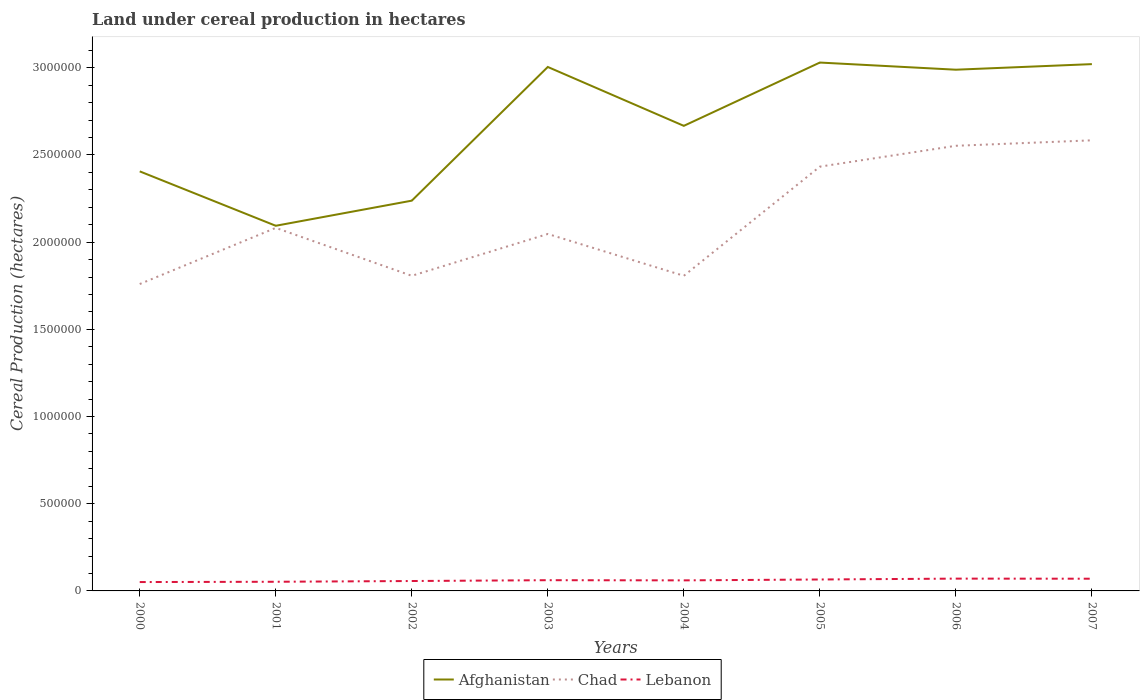Is the number of lines equal to the number of legend labels?
Offer a terse response. Yes. Across all years, what is the maximum land under cereal production in Lebanon?
Offer a very short reply. 5.08e+04. In which year was the land under cereal production in Chad maximum?
Give a very brief answer. 2000. What is the total land under cereal production in Afghanistan in the graph?
Provide a succinct answer. -7.67e+05. What is the difference between the highest and the second highest land under cereal production in Lebanon?
Keep it short and to the point. 1.97e+04. What is the difference between the highest and the lowest land under cereal production in Afghanistan?
Your answer should be very brief. 4. Is the land under cereal production in Chad strictly greater than the land under cereal production in Afghanistan over the years?
Provide a short and direct response. Yes. How many lines are there?
Your answer should be compact. 3. How many years are there in the graph?
Make the answer very short. 8. Are the values on the major ticks of Y-axis written in scientific E-notation?
Offer a very short reply. No. Where does the legend appear in the graph?
Provide a succinct answer. Bottom center. How are the legend labels stacked?
Keep it short and to the point. Horizontal. What is the title of the graph?
Provide a succinct answer. Land under cereal production in hectares. Does "Bolivia" appear as one of the legend labels in the graph?
Your answer should be compact. No. What is the label or title of the X-axis?
Provide a short and direct response. Years. What is the label or title of the Y-axis?
Make the answer very short. Cereal Production (hectares). What is the Cereal Production (hectares) of Afghanistan in 2000?
Ensure brevity in your answer.  2.41e+06. What is the Cereal Production (hectares) in Chad in 2000?
Offer a terse response. 1.76e+06. What is the Cereal Production (hectares) of Lebanon in 2000?
Ensure brevity in your answer.  5.08e+04. What is the Cereal Production (hectares) in Afghanistan in 2001?
Offer a terse response. 2.09e+06. What is the Cereal Production (hectares) of Chad in 2001?
Make the answer very short. 2.08e+06. What is the Cereal Production (hectares) of Lebanon in 2001?
Ensure brevity in your answer.  5.25e+04. What is the Cereal Production (hectares) in Afghanistan in 2002?
Provide a short and direct response. 2.24e+06. What is the Cereal Production (hectares) in Chad in 2002?
Your response must be concise. 1.81e+06. What is the Cereal Production (hectares) of Lebanon in 2002?
Offer a terse response. 5.68e+04. What is the Cereal Production (hectares) in Afghanistan in 2003?
Your answer should be compact. 3.00e+06. What is the Cereal Production (hectares) of Chad in 2003?
Provide a succinct answer. 2.05e+06. What is the Cereal Production (hectares) in Lebanon in 2003?
Offer a terse response. 6.15e+04. What is the Cereal Production (hectares) of Afghanistan in 2004?
Offer a terse response. 2.67e+06. What is the Cereal Production (hectares) in Chad in 2004?
Keep it short and to the point. 1.81e+06. What is the Cereal Production (hectares) of Lebanon in 2004?
Provide a succinct answer. 6.05e+04. What is the Cereal Production (hectares) of Afghanistan in 2005?
Offer a very short reply. 3.03e+06. What is the Cereal Production (hectares) in Chad in 2005?
Provide a short and direct response. 2.43e+06. What is the Cereal Production (hectares) of Lebanon in 2005?
Give a very brief answer. 6.56e+04. What is the Cereal Production (hectares) of Afghanistan in 2006?
Ensure brevity in your answer.  2.99e+06. What is the Cereal Production (hectares) of Chad in 2006?
Your response must be concise. 2.55e+06. What is the Cereal Production (hectares) of Lebanon in 2006?
Make the answer very short. 7.05e+04. What is the Cereal Production (hectares) in Afghanistan in 2007?
Your answer should be very brief. 3.02e+06. What is the Cereal Production (hectares) of Chad in 2007?
Provide a succinct answer. 2.58e+06. What is the Cereal Production (hectares) in Lebanon in 2007?
Give a very brief answer. 7.00e+04. Across all years, what is the maximum Cereal Production (hectares) of Afghanistan?
Provide a short and direct response. 3.03e+06. Across all years, what is the maximum Cereal Production (hectares) in Chad?
Your answer should be very brief. 2.58e+06. Across all years, what is the maximum Cereal Production (hectares) of Lebanon?
Keep it short and to the point. 7.05e+04. Across all years, what is the minimum Cereal Production (hectares) in Afghanistan?
Ensure brevity in your answer.  2.09e+06. Across all years, what is the minimum Cereal Production (hectares) in Chad?
Provide a short and direct response. 1.76e+06. Across all years, what is the minimum Cereal Production (hectares) in Lebanon?
Make the answer very short. 5.08e+04. What is the total Cereal Production (hectares) in Afghanistan in the graph?
Your answer should be compact. 2.14e+07. What is the total Cereal Production (hectares) in Chad in the graph?
Your response must be concise. 1.71e+07. What is the total Cereal Production (hectares) in Lebanon in the graph?
Provide a short and direct response. 4.88e+05. What is the difference between the Cereal Production (hectares) in Afghanistan in 2000 and that in 2001?
Your answer should be very brief. 3.12e+05. What is the difference between the Cereal Production (hectares) of Chad in 2000 and that in 2001?
Give a very brief answer. -3.22e+05. What is the difference between the Cereal Production (hectares) of Lebanon in 2000 and that in 2001?
Offer a terse response. -1679. What is the difference between the Cereal Production (hectares) in Afghanistan in 2000 and that in 2002?
Offer a terse response. 1.68e+05. What is the difference between the Cereal Production (hectares) in Chad in 2000 and that in 2002?
Give a very brief answer. -4.72e+04. What is the difference between the Cereal Production (hectares) in Lebanon in 2000 and that in 2002?
Ensure brevity in your answer.  -5946. What is the difference between the Cereal Production (hectares) in Afghanistan in 2000 and that in 2003?
Your answer should be compact. -5.99e+05. What is the difference between the Cereal Production (hectares) of Chad in 2000 and that in 2003?
Offer a very short reply. -2.87e+05. What is the difference between the Cereal Production (hectares) in Lebanon in 2000 and that in 2003?
Your answer should be compact. -1.07e+04. What is the difference between the Cereal Production (hectares) in Afghanistan in 2000 and that in 2004?
Provide a succinct answer. -2.61e+05. What is the difference between the Cereal Production (hectares) of Chad in 2000 and that in 2004?
Provide a succinct answer. -4.72e+04. What is the difference between the Cereal Production (hectares) of Lebanon in 2000 and that in 2004?
Ensure brevity in your answer.  -9691. What is the difference between the Cereal Production (hectares) of Afghanistan in 2000 and that in 2005?
Your answer should be compact. -6.24e+05. What is the difference between the Cereal Production (hectares) in Chad in 2000 and that in 2005?
Offer a very short reply. -6.73e+05. What is the difference between the Cereal Production (hectares) of Lebanon in 2000 and that in 2005?
Your answer should be very brief. -1.47e+04. What is the difference between the Cereal Production (hectares) of Afghanistan in 2000 and that in 2006?
Keep it short and to the point. -5.83e+05. What is the difference between the Cereal Production (hectares) in Chad in 2000 and that in 2006?
Offer a very short reply. -7.93e+05. What is the difference between the Cereal Production (hectares) in Lebanon in 2000 and that in 2006?
Make the answer very short. -1.97e+04. What is the difference between the Cereal Production (hectares) of Afghanistan in 2000 and that in 2007?
Keep it short and to the point. -6.15e+05. What is the difference between the Cereal Production (hectares) in Chad in 2000 and that in 2007?
Give a very brief answer. -8.24e+05. What is the difference between the Cereal Production (hectares) of Lebanon in 2000 and that in 2007?
Your answer should be very brief. -1.92e+04. What is the difference between the Cereal Production (hectares) of Afghanistan in 2001 and that in 2002?
Ensure brevity in your answer.  -1.44e+05. What is the difference between the Cereal Production (hectares) of Chad in 2001 and that in 2002?
Your response must be concise. 2.75e+05. What is the difference between the Cereal Production (hectares) in Lebanon in 2001 and that in 2002?
Your answer should be very brief. -4267. What is the difference between the Cereal Production (hectares) of Afghanistan in 2001 and that in 2003?
Your answer should be very brief. -9.11e+05. What is the difference between the Cereal Production (hectares) of Chad in 2001 and that in 2003?
Offer a terse response. 3.49e+04. What is the difference between the Cereal Production (hectares) in Lebanon in 2001 and that in 2003?
Offer a very short reply. -8992. What is the difference between the Cereal Production (hectares) in Afghanistan in 2001 and that in 2004?
Offer a terse response. -5.73e+05. What is the difference between the Cereal Production (hectares) of Chad in 2001 and that in 2004?
Offer a very short reply. 2.75e+05. What is the difference between the Cereal Production (hectares) in Lebanon in 2001 and that in 2004?
Offer a very short reply. -8012. What is the difference between the Cereal Production (hectares) of Afghanistan in 2001 and that in 2005?
Give a very brief answer. -9.36e+05. What is the difference between the Cereal Production (hectares) in Chad in 2001 and that in 2005?
Your answer should be very brief. -3.51e+05. What is the difference between the Cereal Production (hectares) of Lebanon in 2001 and that in 2005?
Provide a succinct answer. -1.30e+04. What is the difference between the Cereal Production (hectares) in Afghanistan in 2001 and that in 2006?
Your answer should be very brief. -8.95e+05. What is the difference between the Cereal Production (hectares) of Chad in 2001 and that in 2006?
Ensure brevity in your answer.  -4.71e+05. What is the difference between the Cereal Production (hectares) of Lebanon in 2001 and that in 2006?
Your answer should be very brief. -1.80e+04. What is the difference between the Cereal Production (hectares) of Afghanistan in 2001 and that in 2007?
Make the answer very short. -9.27e+05. What is the difference between the Cereal Production (hectares) in Chad in 2001 and that in 2007?
Provide a succinct answer. -5.02e+05. What is the difference between the Cereal Production (hectares) in Lebanon in 2001 and that in 2007?
Ensure brevity in your answer.  -1.75e+04. What is the difference between the Cereal Production (hectares) in Afghanistan in 2002 and that in 2003?
Keep it short and to the point. -7.67e+05. What is the difference between the Cereal Production (hectares) in Chad in 2002 and that in 2003?
Offer a terse response. -2.40e+05. What is the difference between the Cereal Production (hectares) in Lebanon in 2002 and that in 2003?
Make the answer very short. -4725. What is the difference between the Cereal Production (hectares) in Afghanistan in 2002 and that in 2004?
Offer a very short reply. -4.29e+05. What is the difference between the Cereal Production (hectares) in Chad in 2002 and that in 2004?
Ensure brevity in your answer.  18. What is the difference between the Cereal Production (hectares) of Lebanon in 2002 and that in 2004?
Offer a very short reply. -3745. What is the difference between the Cereal Production (hectares) in Afghanistan in 2002 and that in 2005?
Give a very brief answer. -7.92e+05. What is the difference between the Cereal Production (hectares) in Chad in 2002 and that in 2005?
Keep it short and to the point. -6.26e+05. What is the difference between the Cereal Production (hectares) of Lebanon in 2002 and that in 2005?
Provide a succinct answer. -8774. What is the difference between the Cereal Production (hectares) of Afghanistan in 2002 and that in 2006?
Your response must be concise. -7.51e+05. What is the difference between the Cereal Production (hectares) of Chad in 2002 and that in 2006?
Your answer should be compact. -7.46e+05. What is the difference between the Cereal Production (hectares) in Lebanon in 2002 and that in 2006?
Your response must be concise. -1.37e+04. What is the difference between the Cereal Production (hectares) of Afghanistan in 2002 and that in 2007?
Your response must be concise. -7.83e+05. What is the difference between the Cereal Production (hectares) of Chad in 2002 and that in 2007?
Give a very brief answer. -7.77e+05. What is the difference between the Cereal Production (hectares) of Lebanon in 2002 and that in 2007?
Your answer should be very brief. -1.32e+04. What is the difference between the Cereal Production (hectares) in Afghanistan in 2003 and that in 2004?
Your answer should be compact. 3.38e+05. What is the difference between the Cereal Production (hectares) of Chad in 2003 and that in 2004?
Provide a short and direct response. 2.40e+05. What is the difference between the Cereal Production (hectares) of Lebanon in 2003 and that in 2004?
Your response must be concise. 980. What is the difference between the Cereal Production (hectares) in Afghanistan in 2003 and that in 2005?
Offer a very short reply. -2.53e+04. What is the difference between the Cereal Production (hectares) in Chad in 2003 and that in 2005?
Your answer should be very brief. -3.86e+05. What is the difference between the Cereal Production (hectares) of Lebanon in 2003 and that in 2005?
Give a very brief answer. -4049. What is the difference between the Cereal Production (hectares) of Afghanistan in 2003 and that in 2006?
Your answer should be compact. 1.57e+04. What is the difference between the Cereal Production (hectares) in Chad in 2003 and that in 2006?
Ensure brevity in your answer.  -5.06e+05. What is the difference between the Cereal Production (hectares) of Lebanon in 2003 and that in 2006?
Provide a short and direct response. -9024. What is the difference between the Cereal Production (hectares) of Afghanistan in 2003 and that in 2007?
Your answer should be very brief. -1.63e+04. What is the difference between the Cereal Production (hectares) in Chad in 2003 and that in 2007?
Give a very brief answer. -5.37e+05. What is the difference between the Cereal Production (hectares) of Lebanon in 2003 and that in 2007?
Provide a succinct answer. -8519. What is the difference between the Cereal Production (hectares) of Afghanistan in 2004 and that in 2005?
Keep it short and to the point. -3.63e+05. What is the difference between the Cereal Production (hectares) of Chad in 2004 and that in 2005?
Your answer should be compact. -6.26e+05. What is the difference between the Cereal Production (hectares) of Lebanon in 2004 and that in 2005?
Make the answer very short. -5029. What is the difference between the Cereal Production (hectares) of Afghanistan in 2004 and that in 2006?
Your answer should be very brief. -3.22e+05. What is the difference between the Cereal Production (hectares) of Chad in 2004 and that in 2006?
Give a very brief answer. -7.46e+05. What is the difference between the Cereal Production (hectares) in Lebanon in 2004 and that in 2006?
Make the answer very short. -1.00e+04. What is the difference between the Cereal Production (hectares) in Afghanistan in 2004 and that in 2007?
Make the answer very short. -3.54e+05. What is the difference between the Cereal Production (hectares) in Chad in 2004 and that in 2007?
Provide a short and direct response. -7.77e+05. What is the difference between the Cereal Production (hectares) of Lebanon in 2004 and that in 2007?
Provide a succinct answer. -9499. What is the difference between the Cereal Production (hectares) in Afghanistan in 2005 and that in 2006?
Provide a succinct answer. 4.10e+04. What is the difference between the Cereal Production (hectares) of Chad in 2005 and that in 2006?
Give a very brief answer. -1.20e+05. What is the difference between the Cereal Production (hectares) in Lebanon in 2005 and that in 2006?
Provide a short and direct response. -4975. What is the difference between the Cereal Production (hectares) in Afghanistan in 2005 and that in 2007?
Make the answer very short. 9000. What is the difference between the Cereal Production (hectares) in Chad in 2005 and that in 2007?
Provide a short and direct response. -1.51e+05. What is the difference between the Cereal Production (hectares) in Lebanon in 2005 and that in 2007?
Give a very brief answer. -4470. What is the difference between the Cereal Production (hectares) of Afghanistan in 2006 and that in 2007?
Provide a short and direct response. -3.20e+04. What is the difference between the Cereal Production (hectares) in Chad in 2006 and that in 2007?
Ensure brevity in your answer.  -3.13e+04. What is the difference between the Cereal Production (hectares) of Lebanon in 2006 and that in 2007?
Offer a terse response. 505. What is the difference between the Cereal Production (hectares) of Afghanistan in 2000 and the Cereal Production (hectares) of Chad in 2001?
Your response must be concise. 3.24e+05. What is the difference between the Cereal Production (hectares) of Afghanistan in 2000 and the Cereal Production (hectares) of Lebanon in 2001?
Offer a very short reply. 2.35e+06. What is the difference between the Cereal Production (hectares) of Chad in 2000 and the Cereal Production (hectares) of Lebanon in 2001?
Give a very brief answer. 1.71e+06. What is the difference between the Cereal Production (hectares) in Afghanistan in 2000 and the Cereal Production (hectares) in Chad in 2002?
Make the answer very short. 5.99e+05. What is the difference between the Cereal Production (hectares) in Afghanistan in 2000 and the Cereal Production (hectares) in Lebanon in 2002?
Your answer should be very brief. 2.35e+06. What is the difference between the Cereal Production (hectares) in Chad in 2000 and the Cereal Production (hectares) in Lebanon in 2002?
Ensure brevity in your answer.  1.70e+06. What is the difference between the Cereal Production (hectares) in Afghanistan in 2000 and the Cereal Production (hectares) in Chad in 2003?
Offer a terse response. 3.59e+05. What is the difference between the Cereal Production (hectares) in Afghanistan in 2000 and the Cereal Production (hectares) in Lebanon in 2003?
Offer a terse response. 2.34e+06. What is the difference between the Cereal Production (hectares) in Chad in 2000 and the Cereal Production (hectares) in Lebanon in 2003?
Make the answer very short. 1.70e+06. What is the difference between the Cereal Production (hectares) in Afghanistan in 2000 and the Cereal Production (hectares) in Chad in 2004?
Provide a short and direct response. 5.99e+05. What is the difference between the Cereal Production (hectares) of Afghanistan in 2000 and the Cereal Production (hectares) of Lebanon in 2004?
Offer a terse response. 2.35e+06. What is the difference between the Cereal Production (hectares) in Chad in 2000 and the Cereal Production (hectares) in Lebanon in 2004?
Your response must be concise. 1.70e+06. What is the difference between the Cereal Production (hectares) of Afghanistan in 2000 and the Cereal Production (hectares) of Chad in 2005?
Your answer should be very brief. -2.71e+04. What is the difference between the Cereal Production (hectares) of Afghanistan in 2000 and the Cereal Production (hectares) of Lebanon in 2005?
Offer a very short reply. 2.34e+06. What is the difference between the Cereal Production (hectares) in Chad in 2000 and the Cereal Production (hectares) in Lebanon in 2005?
Provide a short and direct response. 1.69e+06. What is the difference between the Cereal Production (hectares) of Afghanistan in 2000 and the Cereal Production (hectares) of Chad in 2006?
Ensure brevity in your answer.  -1.47e+05. What is the difference between the Cereal Production (hectares) in Afghanistan in 2000 and the Cereal Production (hectares) in Lebanon in 2006?
Give a very brief answer. 2.34e+06. What is the difference between the Cereal Production (hectares) of Chad in 2000 and the Cereal Production (hectares) of Lebanon in 2006?
Provide a short and direct response. 1.69e+06. What is the difference between the Cereal Production (hectares) of Afghanistan in 2000 and the Cereal Production (hectares) of Chad in 2007?
Your response must be concise. -1.78e+05. What is the difference between the Cereal Production (hectares) in Afghanistan in 2000 and the Cereal Production (hectares) in Lebanon in 2007?
Give a very brief answer. 2.34e+06. What is the difference between the Cereal Production (hectares) in Chad in 2000 and the Cereal Production (hectares) in Lebanon in 2007?
Keep it short and to the point. 1.69e+06. What is the difference between the Cereal Production (hectares) of Afghanistan in 2001 and the Cereal Production (hectares) of Chad in 2002?
Provide a short and direct response. 2.87e+05. What is the difference between the Cereal Production (hectares) in Afghanistan in 2001 and the Cereal Production (hectares) in Lebanon in 2002?
Keep it short and to the point. 2.04e+06. What is the difference between the Cereal Production (hectares) of Chad in 2001 and the Cereal Production (hectares) of Lebanon in 2002?
Ensure brevity in your answer.  2.03e+06. What is the difference between the Cereal Production (hectares) in Afghanistan in 2001 and the Cereal Production (hectares) in Chad in 2003?
Your response must be concise. 4.70e+04. What is the difference between the Cereal Production (hectares) of Afghanistan in 2001 and the Cereal Production (hectares) of Lebanon in 2003?
Provide a succinct answer. 2.03e+06. What is the difference between the Cereal Production (hectares) of Chad in 2001 and the Cereal Production (hectares) of Lebanon in 2003?
Provide a succinct answer. 2.02e+06. What is the difference between the Cereal Production (hectares) of Afghanistan in 2001 and the Cereal Production (hectares) of Chad in 2004?
Ensure brevity in your answer.  2.87e+05. What is the difference between the Cereal Production (hectares) in Afghanistan in 2001 and the Cereal Production (hectares) in Lebanon in 2004?
Your answer should be compact. 2.03e+06. What is the difference between the Cereal Production (hectares) in Chad in 2001 and the Cereal Production (hectares) in Lebanon in 2004?
Offer a very short reply. 2.02e+06. What is the difference between the Cereal Production (hectares) in Afghanistan in 2001 and the Cereal Production (hectares) in Chad in 2005?
Provide a succinct answer. -3.39e+05. What is the difference between the Cereal Production (hectares) of Afghanistan in 2001 and the Cereal Production (hectares) of Lebanon in 2005?
Provide a succinct answer. 2.03e+06. What is the difference between the Cereal Production (hectares) of Chad in 2001 and the Cereal Production (hectares) of Lebanon in 2005?
Ensure brevity in your answer.  2.02e+06. What is the difference between the Cereal Production (hectares) in Afghanistan in 2001 and the Cereal Production (hectares) in Chad in 2006?
Keep it short and to the point. -4.59e+05. What is the difference between the Cereal Production (hectares) in Afghanistan in 2001 and the Cereal Production (hectares) in Lebanon in 2006?
Offer a very short reply. 2.02e+06. What is the difference between the Cereal Production (hectares) in Chad in 2001 and the Cereal Production (hectares) in Lebanon in 2006?
Your answer should be very brief. 2.01e+06. What is the difference between the Cereal Production (hectares) in Afghanistan in 2001 and the Cereal Production (hectares) in Chad in 2007?
Provide a short and direct response. -4.90e+05. What is the difference between the Cereal Production (hectares) in Afghanistan in 2001 and the Cereal Production (hectares) in Lebanon in 2007?
Your answer should be very brief. 2.02e+06. What is the difference between the Cereal Production (hectares) in Chad in 2001 and the Cereal Production (hectares) in Lebanon in 2007?
Give a very brief answer. 2.01e+06. What is the difference between the Cereal Production (hectares) of Afghanistan in 2002 and the Cereal Production (hectares) of Chad in 2003?
Give a very brief answer. 1.91e+05. What is the difference between the Cereal Production (hectares) in Afghanistan in 2002 and the Cereal Production (hectares) in Lebanon in 2003?
Offer a terse response. 2.18e+06. What is the difference between the Cereal Production (hectares) of Chad in 2002 and the Cereal Production (hectares) of Lebanon in 2003?
Your answer should be very brief. 1.75e+06. What is the difference between the Cereal Production (hectares) in Afghanistan in 2002 and the Cereal Production (hectares) in Chad in 2004?
Your answer should be compact. 4.31e+05. What is the difference between the Cereal Production (hectares) in Afghanistan in 2002 and the Cereal Production (hectares) in Lebanon in 2004?
Keep it short and to the point. 2.18e+06. What is the difference between the Cereal Production (hectares) of Chad in 2002 and the Cereal Production (hectares) of Lebanon in 2004?
Provide a succinct answer. 1.75e+06. What is the difference between the Cereal Production (hectares) of Afghanistan in 2002 and the Cereal Production (hectares) of Chad in 2005?
Give a very brief answer. -1.95e+05. What is the difference between the Cereal Production (hectares) of Afghanistan in 2002 and the Cereal Production (hectares) of Lebanon in 2005?
Provide a short and direct response. 2.17e+06. What is the difference between the Cereal Production (hectares) in Chad in 2002 and the Cereal Production (hectares) in Lebanon in 2005?
Keep it short and to the point. 1.74e+06. What is the difference between the Cereal Production (hectares) in Afghanistan in 2002 and the Cereal Production (hectares) in Chad in 2006?
Your answer should be very brief. -3.15e+05. What is the difference between the Cereal Production (hectares) of Afghanistan in 2002 and the Cereal Production (hectares) of Lebanon in 2006?
Provide a succinct answer. 2.17e+06. What is the difference between the Cereal Production (hectares) in Chad in 2002 and the Cereal Production (hectares) in Lebanon in 2006?
Give a very brief answer. 1.74e+06. What is the difference between the Cereal Production (hectares) of Afghanistan in 2002 and the Cereal Production (hectares) of Chad in 2007?
Keep it short and to the point. -3.46e+05. What is the difference between the Cereal Production (hectares) in Afghanistan in 2002 and the Cereal Production (hectares) in Lebanon in 2007?
Make the answer very short. 2.17e+06. What is the difference between the Cereal Production (hectares) in Chad in 2002 and the Cereal Production (hectares) in Lebanon in 2007?
Make the answer very short. 1.74e+06. What is the difference between the Cereal Production (hectares) in Afghanistan in 2003 and the Cereal Production (hectares) in Chad in 2004?
Make the answer very short. 1.20e+06. What is the difference between the Cereal Production (hectares) of Afghanistan in 2003 and the Cereal Production (hectares) of Lebanon in 2004?
Give a very brief answer. 2.94e+06. What is the difference between the Cereal Production (hectares) of Chad in 2003 and the Cereal Production (hectares) of Lebanon in 2004?
Provide a short and direct response. 1.99e+06. What is the difference between the Cereal Production (hectares) of Afghanistan in 2003 and the Cereal Production (hectares) of Chad in 2005?
Keep it short and to the point. 5.72e+05. What is the difference between the Cereal Production (hectares) in Afghanistan in 2003 and the Cereal Production (hectares) in Lebanon in 2005?
Keep it short and to the point. 2.94e+06. What is the difference between the Cereal Production (hectares) in Chad in 2003 and the Cereal Production (hectares) in Lebanon in 2005?
Give a very brief answer. 1.98e+06. What is the difference between the Cereal Production (hectares) in Afghanistan in 2003 and the Cereal Production (hectares) in Chad in 2006?
Offer a very short reply. 4.52e+05. What is the difference between the Cereal Production (hectares) in Afghanistan in 2003 and the Cereal Production (hectares) in Lebanon in 2006?
Provide a short and direct response. 2.93e+06. What is the difference between the Cereal Production (hectares) of Chad in 2003 and the Cereal Production (hectares) of Lebanon in 2006?
Offer a terse response. 1.98e+06. What is the difference between the Cereal Production (hectares) of Afghanistan in 2003 and the Cereal Production (hectares) of Chad in 2007?
Provide a succinct answer. 4.21e+05. What is the difference between the Cereal Production (hectares) of Afghanistan in 2003 and the Cereal Production (hectares) of Lebanon in 2007?
Make the answer very short. 2.93e+06. What is the difference between the Cereal Production (hectares) of Chad in 2003 and the Cereal Production (hectares) of Lebanon in 2007?
Ensure brevity in your answer.  1.98e+06. What is the difference between the Cereal Production (hectares) in Afghanistan in 2004 and the Cereal Production (hectares) in Chad in 2005?
Provide a succinct answer. 2.34e+05. What is the difference between the Cereal Production (hectares) in Afghanistan in 2004 and the Cereal Production (hectares) in Lebanon in 2005?
Provide a succinct answer. 2.60e+06. What is the difference between the Cereal Production (hectares) in Chad in 2004 and the Cereal Production (hectares) in Lebanon in 2005?
Keep it short and to the point. 1.74e+06. What is the difference between the Cereal Production (hectares) in Afghanistan in 2004 and the Cereal Production (hectares) in Chad in 2006?
Offer a very short reply. 1.14e+05. What is the difference between the Cereal Production (hectares) in Afghanistan in 2004 and the Cereal Production (hectares) in Lebanon in 2006?
Offer a terse response. 2.60e+06. What is the difference between the Cereal Production (hectares) of Chad in 2004 and the Cereal Production (hectares) of Lebanon in 2006?
Offer a very short reply. 1.74e+06. What is the difference between the Cereal Production (hectares) of Afghanistan in 2004 and the Cereal Production (hectares) of Chad in 2007?
Provide a succinct answer. 8.30e+04. What is the difference between the Cereal Production (hectares) in Afghanistan in 2004 and the Cereal Production (hectares) in Lebanon in 2007?
Keep it short and to the point. 2.60e+06. What is the difference between the Cereal Production (hectares) of Chad in 2004 and the Cereal Production (hectares) of Lebanon in 2007?
Provide a succinct answer. 1.74e+06. What is the difference between the Cereal Production (hectares) of Afghanistan in 2005 and the Cereal Production (hectares) of Chad in 2006?
Make the answer very short. 4.77e+05. What is the difference between the Cereal Production (hectares) in Afghanistan in 2005 and the Cereal Production (hectares) in Lebanon in 2006?
Make the answer very short. 2.96e+06. What is the difference between the Cereal Production (hectares) in Chad in 2005 and the Cereal Production (hectares) in Lebanon in 2006?
Provide a short and direct response. 2.36e+06. What is the difference between the Cereal Production (hectares) of Afghanistan in 2005 and the Cereal Production (hectares) of Chad in 2007?
Provide a succinct answer. 4.46e+05. What is the difference between the Cereal Production (hectares) in Afghanistan in 2005 and the Cereal Production (hectares) in Lebanon in 2007?
Give a very brief answer. 2.96e+06. What is the difference between the Cereal Production (hectares) in Chad in 2005 and the Cereal Production (hectares) in Lebanon in 2007?
Provide a succinct answer. 2.36e+06. What is the difference between the Cereal Production (hectares) of Afghanistan in 2006 and the Cereal Production (hectares) of Chad in 2007?
Your response must be concise. 4.05e+05. What is the difference between the Cereal Production (hectares) in Afghanistan in 2006 and the Cereal Production (hectares) in Lebanon in 2007?
Your response must be concise. 2.92e+06. What is the difference between the Cereal Production (hectares) of Chad in 2006 and the Cereal Production (hectares) of Lebanon in 2007?
Provide a short and direct response. 2.48e+06. What is the average Cereal Production (hectares) of Afghanistan per year?
Offer a terse response. 2.68e+06. What is the average Cereal Production (hectares) of Chad per year?
Provide a succinct answer. 2.13e+06. What is the average Cereal Production (hectares) in Lebanon per year?
Your answer should be compact. 6.10e+04. In the year 2000, what is the difference between the Cereal Production (hectares) in Afghanistan and Cereal Production (hectares) in Chad?
Offer a very short reply. 6.46e+05. In the year 2000, what is the difference between the Cereal Production (hectares) of Afghanistan and Cereal Production (hectares) of Lebanon?
Your response must be concise. 2.36e+06. In the year 2000, what is the difference between the Cereal Production (hectares) in Chad and Cereal Production (hectares) in Lebanon?
Provide a succinct answer. 1.71e+06. In the year 2001, what is the difference between the Cereal Production (hectares) in Afghanistan and Cereal Production (hectares) in Chad?
Your answer should be compact. 1.21e+04. In the year 2001, what is the difference between the Cereal Production (hectares) of Afghanistan and Cereal Production (hectares) of Lebanon?
Your answer should be very brief. 2.04e+06. In the year 2001, what is the difference between the Cereal Production (hectares) in Chad and Cereal Production (hectares) in Lebanon?
Offer a terse response. 2.03e+06. In the year 2002, what is the difference between the Cereal Production (hectares) in Afghanistan and Cereal Production (hectares) in Chad?
Provide a short and direct response. 4.31e+05. In the year 2002, what is the difference between the Cereal Production (hectares) in Afghanistan and Cereal Production (hectares) in Lebanon?
Your answer should be very brief. 2.18e+06. In the year 2002, what is the difference between the Cereal Production (hectares) of Chad and Cereal Production (hectares) of Lebanon?
Provide a short and direct response. 1.75e+06. In the year 2003, what is the difference between the Cereal Production (hectares) in Afghanistan and Cereal Production (hectares) in Chad?
Offer a terse response. 9.58e+05. In the year 2003, what is the difference between the Cereal Production (hectares) of Afghanistan and Cereal Production (hectares) of Lebanon?
Your answer should be compact. 2.94e+06. In the year 2003, what is the difference between the Cereal Production (hectares) of Chad and Cereal Production (hectares) of Lebanon?
Provide a short and direct response. 1.99e+06. In the year 2004, what is the difference between the Cereal Production (hectares) in Afghanistan and Cereal Production (hectares) in Chad?
Provide a short and direct response. 8.60e+05. In the year 2004, what is the difference between the Cereal Production (hectares) in Afghanistan and Cereal Production (hectares) in Lebanon?
Offer a very short reply. 2.61e+06. In the year 2004, what is the difference between the Cereal Production (hectares) of Chad and Cereal Production (hectares) of Lebanon?
Provide a short and direct response. 1.75e+06. In the year 2005, what is the difference between the Cereal Production (hectares) of Afghanistan and Cereal Production (hectares) of Chad?
Offer a terse response. 5.97e+05. In the year 2005, what is the difference between the Cereal Production (hectares) of Afghanistan and Cereal Production (hectares) of Lebanon?
Your answer should be very brief. 2.96e+06. In the year 2005, what is the difference between the Cereal Production (hectares) in Chad and Cereal Production (hectares) in Lebanon?
Make the answer very short. 2.37e+06. In the year 2006, what is the difference between the Cereal Production (hectares) of Afghanistan and Cereal Production (hectares) of Chad?
Your response must be concise. 4.36e+05. In the year 2006, what is the difference between the Cereal Production (hectares) of Afghanistan and Cereal Production (hectares) of Lebanon?
Provide a succinct answer. 2.92e+06. In the year 2006, what is the difference between the Cereal Production (hectares) of Chad and Cereal Production (hectares) of Lebanon?
Offer a terse response. 2.48e+06. In the year 2007, what is the difference between the Cereal Production (hectares) in Afghanistan and Cereal Production (hectares) in Chad?
Your answer should be very brief. 4.37e+05. In the year 2007, what is the difference between the Cereal Production (hectares) in Afghanistan and Cereal Production (hectares) in Lebanon?
Give a very brief answer. 2.95e+06. In the year 2007, what is the difference between the Cereal Production (hectares) of Chad and Cereal Production (hectares) of Lebanon?
Your response must be concise. 2.51e+06. What is the ratio of the Cereal Production (hectares) of Afghanistan in 2000 to that in 2001?
Keep it short and to the point. 1.15. What is the ratio of the Cereal Production (hectares) of Chad in 2000 to that in 2001?
Provide a succinct answer. 0.85. What is the ratio of the Cereal Production (hectares) of Lebanon in 2000 to that in 2001?
Ensure brevity in your answer.  0.97. What is the ratio of the Cereal Production (hectares) in Afghanistan in 2000 to that in 2002?
Your answer should be very brief. 1.08. What is the ratio of the Cereal Production (hectares) of Chad in 2000 to that in 2002?
Ensure brevity in your answer.  0.97. What is the ratio of the Cereal Production (hectares) in Lebanon in 2000 to that in 2002?
Offer a terse response. 0.9. What is the ratio of the Cereal Production (hectares) in Afghanistan in 2000 to that in 2003?
Offer a very short reply. 0.8. What is the ratio of the Cereal Production (hectares) of Chad in 2000 to that in 2003?
Provide a succinct answer. 0.86. What is the ratio of the Cereal Production (hectares) of Lebanon in 2000 to that in 2003?
Make the answer very short. 0.83. What is the ratio of the Cereal Production (hectares) of Afghanistan in 2000 to that in 2004?
Provide a short and direct response. 0.9. What is the ratio of the Cereal Production (hectares) of Chad in 2000 to that in 2004?
Ensure brevity in your answer.  0.97. What is the ratio of the Cereal Production (hectares) in Lebanon in 2000 to that in 2004?
Offer a very short reply. 0.84. What is the ratio of the Cereal Production (hectares) of Afghanistan in 2000 to that in 2005?
Provide a succinct answer. 0.79. What is the ratio of the Cereal Production (hectares) of Chad in 2000 to that in 2005?
Offer a very short reply. 0.72. What is the ratio of the Cereal Production (hectares) of Lebanon in 2000 to that in 2005?
Ensure brevity in your answer.  0.78. What is the ratio of the Cereal Production (hectares) in Afghanistan in 2000 to that in 2006?
Your answer should be very brief. 0.81. What is the ratio of the Cereal Production (hectares) of Chad in 2000 to that in 2006?
Keep it short and to the point. 0.69. What is the ratio of the Cereal Production (hectares) in Lebanon in 2000 to that in 2006?
Keep it short and to the point. 0.72. What is the ratio of the Cereal Production (hectares) of Afghanistan in 2000 to that in 2007?
Offer a terse response. 0.8. What is the ratio of the Cereal Production (hectares) in Chad in 2000 to that in 2007?
Give a very brief answer. 0.68. What is the ratio of the Cereal Production (hectares) in Lebanon in 2000 to that in 2007?
Your response must be concise. 0.73. What is the ratio of the Cereal Production (hectares) in Afghanistan in 2001 to that in 2002?
Provide a short and direct response. 0.94. What is the ratio of the Cereal Production (hectares) of Chad in 2001 to that in 2002?
Provide a succinct answer. 1.15. What is the ratio of the Cereal Production (hectares) of Lebanon in 2001 to that in 2002?
Give a very brief answer. 0.92. What is the ratio of the Cereal Production (hectares) in Afghanistan in 2001 to that in 2003?
Your answer should be very brief. 0.7. What is the ratio of the Cereal Production (hectares) of Lebanon in 2001 to that in 2003?
Offer a terse response. 0.85. What is the ratio of the Cereal Production (hectares) in Afghanistan in 2001 to that in 2004?
Keep it short and to the point. 0.79. What is the ratio of the Cereal Production (hectares) of Chad in 2001 to that in 2004?
Make the answer very short. 1.15. What is the ratio of the Cereal Production (hectares) of Lebanon in 2001 to that in 2004?
Keep it short and to the point. 0.87. What is the ratio of the Cereal Production (hectares) in Afghanistan in 2001 to that in 2005?
Provide a succinct answer. 0.69. What is the ratio of the Cereal Production (hectares) of Chad in 2001 to that in 2005?
Keep it short and to the point. 0.86. What is the ratio of the Cereal Production (hectares) of Lebanon in 2001 to that in 2005?
Provide a succinct answer. 0.8. What is the ratio of the Cereal Production (hectares) of Afghanistan in 2001 to that in 2006?
Give a very brief answer. 0.7. What is the ratio of the Cereal Production (hectares) of Chad in 2001 to that in 2006?
Your answer should be very brief. 0.82. What is the ratio of the Cereal Production (hectares) of Lebanon in 2001 to that in 2006?
Give a very brief answer. 0.74. What is the ratio of the Cereal Production (hectares) of Afghanistan in 2001 to that in 2007?
Provide a short and direct response. 0.69. What is the ratio of the Cereal Production (hectares) in Chad in 2001 to that in 2007?
Keep it short and to the point. 0.81. What is the ratio of the Cereal Production (hectares) in Afghanistan in 2002 to that in 2003?
Provide a short and direct response. 0.74. What is the ratio of the Cereal Production (hectares) in Chad in 2002 to that in 2003?
Keep it short and to the point. 0.88. What is the ratio of the Cereal Production (hectares) of Lebanon in 2002 to that in 2003?
Your answer should be very brief. 0.92. What is the ratio of the Cereal Production (hectares) of Afghanistan in 2002 to that in 2004?
Keep it short and to the point. 0.84. What is the ratio of the Cereal Production (hectares) of Chad in 2002 to that in 2004?
Your response must be concise. 1. What is the ratio of the Cereal Production (hectares) of Lebanon in 2002 to that in 2004?
Provide a succinct answer. 0.94. What is the ratio of the Cereal Production (hectares) in Afghanistan in 2002 to that in 2005?
Your response must be concise. 0.74. What is the ratio of the Cereal Production (hectares) of Chad in 2002 to that in 2005?
Give a very brief answer. 0.74. What is the ratio of the Cereal Production (hectares) of Lebanon in 2002 to that in 2005?
Give a very brief answer. 0.87. What is the ratio of the Cereal Production (hectares) in Afghanistan in 2002 to that in 2006?
Provide a succinct answer. 0.75. What is the ratio of the Cereal Production (hectares) in Chad in 2002 to that in 2006?
Offer a terse response. 0.71. What is the ratio of the Cereal Production (hectares) of Lebanon in 2002 to that in 2006?
Provide a succinct answer. 0.81. What is the ratio of the Cereal Production (hectares) of Afghanistan in 2002 to that in 2007?
Ensure brevity in your answer.  0.74. What is the ratio of the Cereal Production (hectares) of Chad in 2002 to that in 2007?
Give a very brief answer. 0.7. What is the ratio of the Cereal Production (hectares) in Lebanon in 2002 to that in 2007?
Ensure brevity in your answer.  0.81. What is the ratio of the Cereal Production (hectares) of Afghanistan in 2003 to that in 2004?
Provide a succinct answer. 1.13. What is the ratio of the Cereal Production (hectares) of Chad in 2003 to that in 2004?
Your answer should be compact. 1.13. What is the ratio of the Cereal Production (hectares) in Lebanon in 2003 to that in 2004?
Your answer should be very brief. 1.02. What is the ratio of the Cereal Production (hectares) in Chad in 2003 to that in 2005?
Ensure brevity in your answer.  0.84. What is the ratio of the Cereal Production (hectares) in Lebanon in 2003 to that in 2005?
Keep it short and to the point. 0.94. What is the ratio of the Cereal Production (hectares) in Afghanistan in 2003 to that in 2006?
Make the answer very short. 1.01. What is the ratio of the Cereal Production (hectares) in Chad in 2003 to that in 2006?
Your response must be concise. 0.8. What is the ratio of the Cereal Production (hectares) of Lebanon in 2003 to that in 2006?
Offer a very short reply. 0.87. What is the ratio of the Cereal Production (hectares) in Afghanistan in 2003 to that in 2007?
Provide a short and direct response. 0.99. What is the ratio of the Cereal Production (hectares) of Chad in 2003 to that in 2007?
Offer a terse response. 0.79. What is the ratio of the Cereal Production (hectares) of Lebanon in 2003 to that in 2007?
Your answer should be very brief. 0.88. What is the ratio of the Cereal Production (hectares) of Afghanistan in 2004 to that in 2005?
Give a very brief answer. 0.88. What is the ratio of the Cereal Production (hectares) in Chad in 2004 to that in 2005?
Ensure brevity in your answer.  0.74. What is the ratio of the Cereal Production (hectares) in Lebanon in 2004 to that in 2005?
Your answer should be very brief. 0.92. What is the ratio of the Cereal Production (hectares) in Afghanistan in 2004 to that in 2006?
Give a very brief answer. 0.89. What is the ratio of the Cereal Production (hectares) of Chad in 2004 to that in 2006?
Ensure brevity in your answer.  0.71. What is the ratio of the Cereal Production (hectares) in Lebanon in 2004 to that in 2006?
Keep it short and to the point. 0.86. What is the ratio of the Cereal Production (hectares) in Afghanistan in 2004 to that in 2007?
Offer a terse response. 0.88. What is the ratio of the Cereal Production (hectares) in Chad in 2004 to that in 2007?
Provide a succinct answer. 0.7. What is the ratio of the Cereal Production (hectares) of Lebanon in 2004 to that in 2007?
Provide a succinct answer. 0.86. What is the ratio of the Cereal Production (hectares) of Afghanistan in 2005 to that in 2006?
Give a very brief answer. 1.01. What is the ratio of the Cereal Production (hectares) in Chad in 2005 to that in 2006?
Offer a terse response. 0.95. What is the ratio of the Cereal Production (hectares) of Lebanon in 2005 to that in 2006?
Provide a short and direct response. 0.93. What is the ratio of the Cereal Production (hectares) in Chad in 2005 to that in 2007?
Provide a short and direct response. 0.94. What is the ratio of the Cereal Production (hectares) of Lebanon in 2005 to that in 2007?
Give a very brief answer. 0.94. What is the ratio of the Cereal Production (hectares) in Chad in 2006 to that in 2007?
Your response must be concise. 0.99. What is the ratio of the Cereal Production (hectares) of Lebanon in 2006 to that in 2007?
Offer a terse response. 1.01. What is the difference between the highest and the second highest Cereal Production (hectares) of Afghanistan?
Offer a terse response. 9000. What is the difference between the highest and the second highest Cereal Production (hectares) of Chad?
Your answer should be compact. 3.13e+04. What is the difference between the highest and the second highest Cereal Production (hectares) in Lebanon?
Make the answer very short. 505. What is the difference between the highest and the lowest Cereal Production (hectares) in Afghanistan?
Provide a succinct answer. 9.36e+05. What is the difference between the highest and the lowest Cereal Production (hectares) of Chad?
Ensure brevity in your answer.  8.24e+05. What is the difference between the highest and the lowest Cereal Production (hectares) in Lebanon?
Keep it short and to the point. 1.97e+04. 